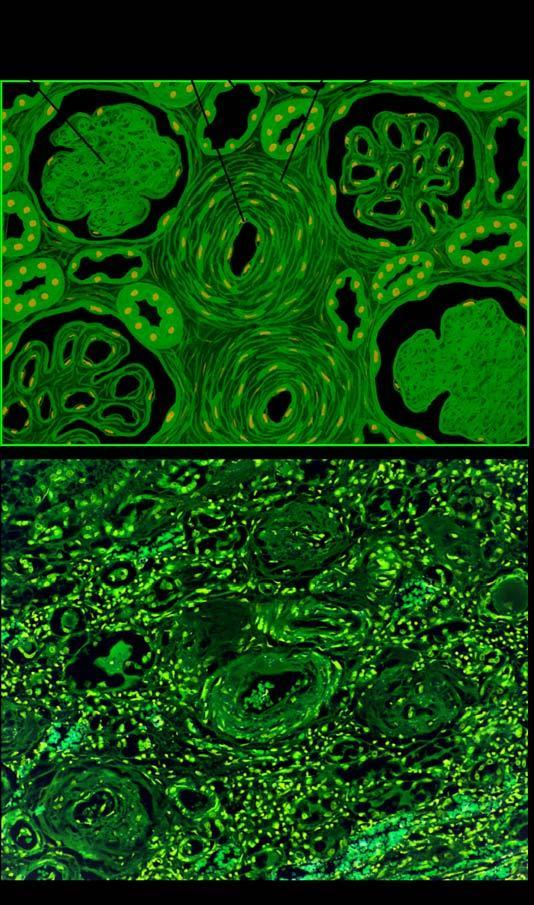do the parenchymal changes include sclerosed glomeruli, tubular atrophy and fine interstitial fibrosis?
Answer the question using a single word or phrase. Yes 